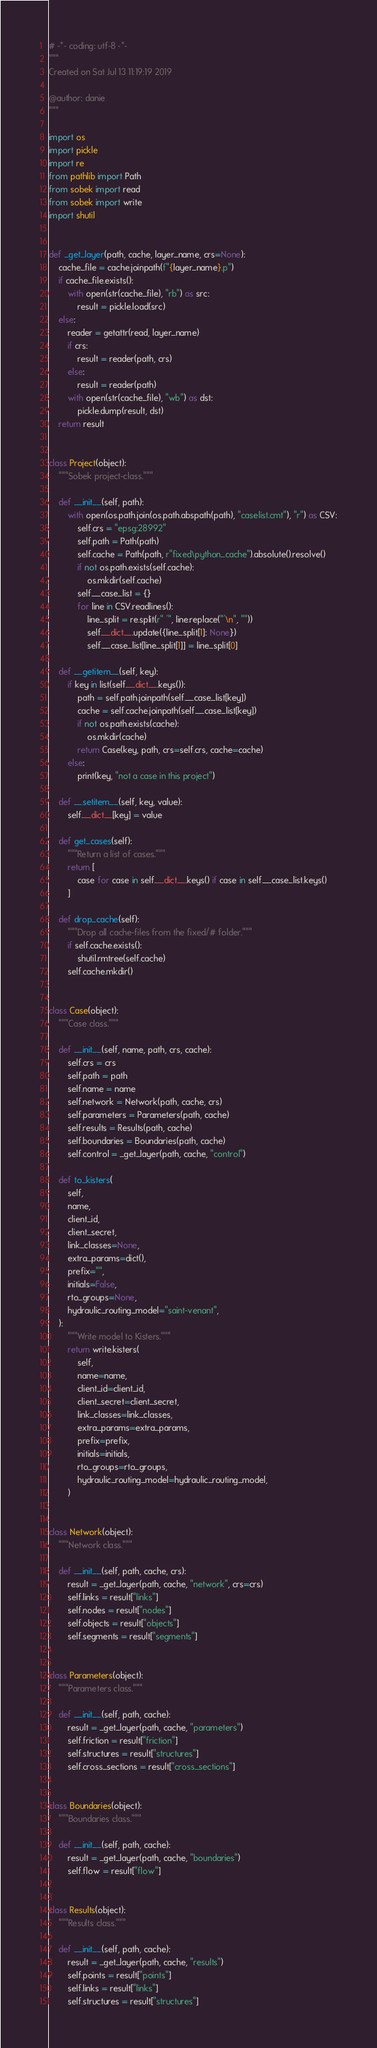<code> <loc_0><loc_0><loc_500><loc_500><_Python_># -*- coding: utf-8 -*-
"""
Created on Sat Jul 13 11:19:19 2019

@author: danie
"""

import os
import pickle
import re
from pathlib import Path
from sobek import read
from sobek import write
import shutil


def _get_layer(path, cache, layer_name, crs=None):
    cache_file = cache.joinpath(f"{layer_name}.p")
    if cache_file.exists():
        with open(str(cache_file), "rb") as src:
            result = pickle.load(src)
    else:
        reader = getattr(read, layer_name)
        if crs:
            result = reader(path, crs)
        else:
            result = reader(path)
        with open(str(cache_file), "wb") as dst:
            pickle.dump(result, dst)
    return result


class Project(object):
    """Sobek project-class."""

    def __init__(self, path):
        with open(os.path.join(os.path.abspath(path), "caselist.cmt"), "r") as CSV:
            self.crs = "epsg:28992"
            self.path = Path(path)
            self.cache = Path(path, r"fixed\python_cache").absolute().resolve()
            if not os.path.exists(self.cache):
                os.mkdir(self.cache)
            self.__case_list = {}
            for line in CSV.readlines():
                line_split = re.split(r" '", line.replace("'\n", ""))
                self.__dict__.update({line_split[1]: None})
                self.__case_list[line_split[1]] = line_split[0]

    def __getitem__(self, key):
        if key in list(self.__dict__.keys()):
            path = self.path.joinpath(self.__case_list[key])
            cache = self.cache.joinpath(self.__case_list[key])
            if not os.path.exists(cache):
                os.mkdir(cache)
            return Case(key, path, crs=self.crs, cache=cache)
        else:
            print(key, "not a case in this project")

    def __setitem__(self, key, value):
        self.__dict__[key] = value

    def get_cases(self):
        """Return a list of cases."""
        return [
            case for case in self.__dict__.keys() if case in self.__case_list.keys()
        ]

    def drop_cache(self):
        """Drop all cache-files from the fixed/# folder."""
        if self.cache.exists():
            shutil.rmtree(self.cache)
        self.cache.mkdir()


class Case(object):
    """Case class."""

    def __init__(self, name, path, crs, cache):
        self.crs = crs
        self.path = path
        self.name = name
        self.network = Network(path, cache, crs)
        self.parameters = Parameters(path, cache)
        self.results = Results(path, cache)
        self.boundaries = Boundaries(path, cache)
        self.control = _get_layer(path, cache, "control")

    def to_kisters(
        self,
        name,
        client_id,
        client_secret,
        link_classes=None,
        extra_params=dict(),
        prefix="",
        initials=False,
        rto_groups=None,
        hydraulic_routing_model="saint-venant",
    ):
        """Write model to Kisters."""
        return write.kisters(
            self,
            name=name,
            client_id=client_id,
            client_secret=client_secret,
            link_classes=link_classes,
            extra_params=extra_params,
            prefix=prefix,
            initials=initials,
            rto_groups=rto_groups,
            hydraulic_routing_model=hydraulic_routing_model,
        )


class Network(object):
    """Network class."""

    def __init__(self, path, cache, crs):
        result = _get_layer(path, cache, "network", crs=crs)
        self.links = result["links"]
        self.nodes = result["nodes"]
        self.objects = result["objects"]
        self.segments = result["segments"]


class Parameters(object):
    """Parameters class."""

    def __init__(self, path, cache):
        result = _get_layer(path, cache, "parameters")
        self.friction = result["friction"]
        self.structures = result["structures"]
        self.cross_sections = result["cross_sections"]


class Boundaries(object):
    """Boundaries class."""

    def __init__(self, path, cache):
        result = _get_layer(path, cache, "boundaries")
        self.flow = result["flow"]


class Results(object):
    """Results class."""

    def __init__(self, path, cache):
        result = _get_layer(path, cache, "results")
        self.points = result["points"]
        self.links = result["links"]
        self.structures = result["structures"]

</code> 